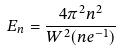<formula> <loc_0><loc_0><loc_500><loc_500>E _ { n } = \frac { 4 \pi ^ { 2 } n ^ { 2 } } { W ^ { 2 } ( n e ^ { - 1 } ) }</formula> 